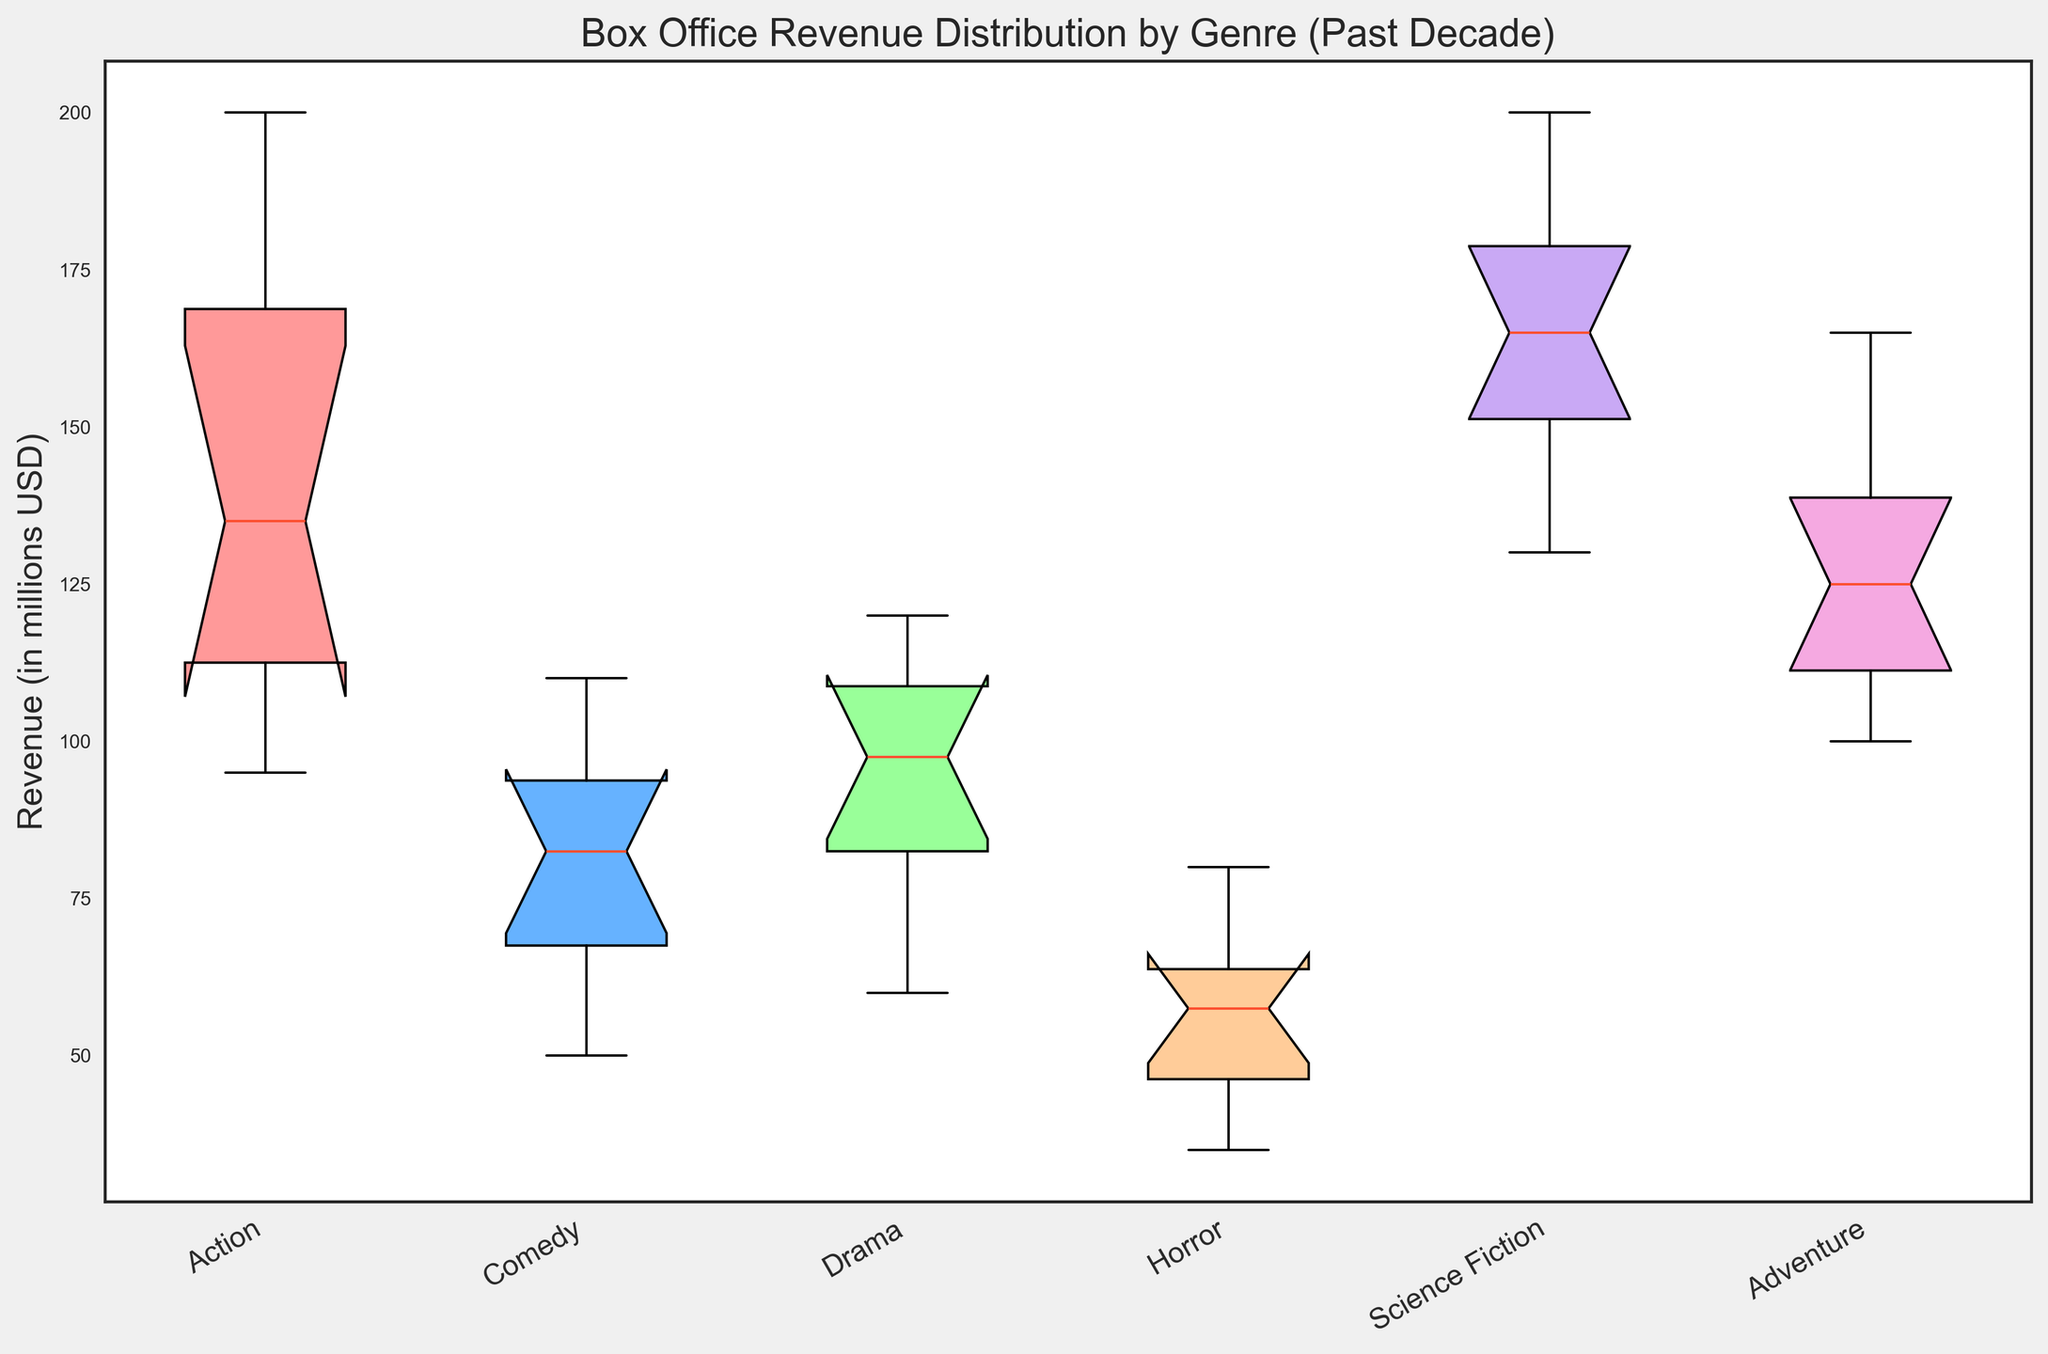What genre shows the highest median revenue? To determine the median revenue, look at the central line inside each box plot. The genre with the highest central line corresponds to the highest median revenue. Science Fiction has the highest median revenue, as its central line is at the highest value.
Answer: Science Fiction Which genre exhibits the greatest range in box office revenue distribution? The range of the box office revenue can be observed by looking at the length of the box plots and the whiskers. The longer the box plot and whiskers, the greater the range. Action shows the greatest range, as its box plot and whiskers span the widest interval.
Answer: Action Compare the median revenue of Comedy and Drama. Which is higher? To compare the medians, examine the central lines in the box plots of Comedy and Drama. The median line in the Drama box plot is higher than in the Comedy box plot.
Answer: Drama Which genre has the smallest interquartile range (IQR)? The IQR is the distance between the first quartile (bottom edge of the box) and the third quartile (top edge of the box). The genre with the shortest box has the smallest IQR. Comedy has the smallest IQR as its box is the shortest.
Answer: Comedy What is the median revenue of Horror movies? Locate the central line inside the box plot for Horror. This line represents the median revenue. The median line for Horror plots slightly above 50, likely around 55.
Answer: 55 Which genre has the highest third quartile (Q3) value, and what is it approximately? The third quartile (Q3) is the top edge of the box in each plot. Identify the genre with the highest top edge and approximate its value. The top edge of Science Fiction is the highest, approximately around 190.
Answer: Science Fiction, around 190 Is the median revenue of Action movies higher than that of Adventure movies? To determine if Action’s median is higher, compare the central lines of their respective box plots. The median line of Action is slightly lower than that of Adventure.
Answer: No Which genre has the largest difference between the median and the first quartile (Q1)? The difference between the median and Q1 can be determined by measuring the distance between the central line and the bottom edge of the box. Action shows the largest difference as the distance between its median and Q1 is the greatest.
Answer: Action Which genre has outliers, if any? Outliers typically appear as individual points outside the whiskers. Identify any genres with such points. No genre in the data has visible outliers.
Answer: None 